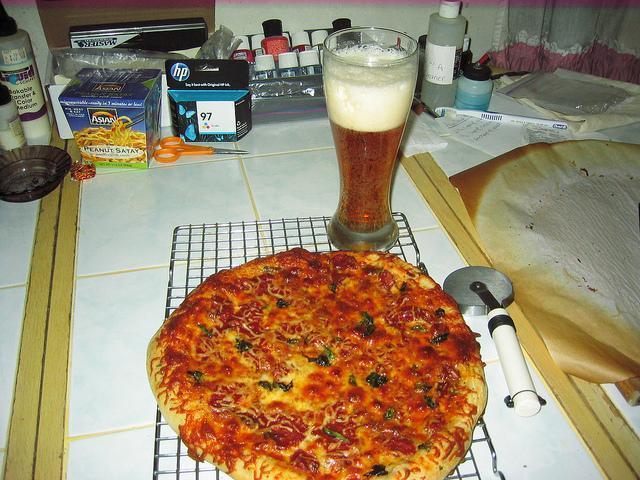How many pizzas are in the photo?
Give a very brief answer. 1. How many bottles are there?
Give a very brief answer. 2. 